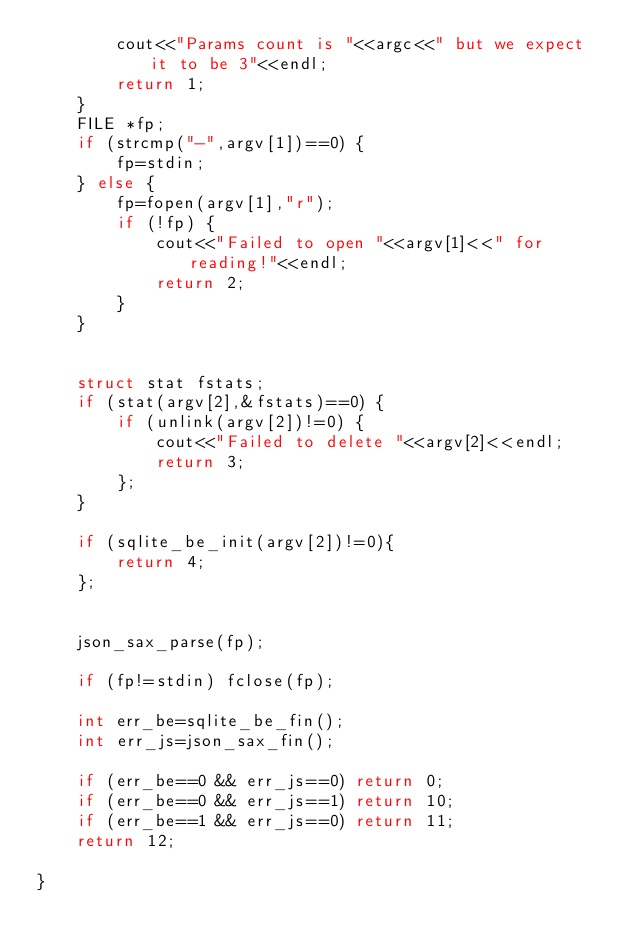Convert code to text. <code><loc_0><loc_0><loc_500><loc_500><_C++_>		cout<<"Params count is "<<argc<<" but we expect it to be 3"<<endl;
		return 1;
	}
	FILE *fp;
	if (strcmp("-",argv[1])==0) {
		fp=stdin;
	} else {
		fp=fopen(argv[1],"r");
		if (!fp) {
			cout<<"Failed to open "<<argv[1]<<" for reading!"<<endl;
			return 2;
		}
	}
	

	struct stat fstats;
	if (stat(argv[2],&fstats)==0) {
		if (unlink(argv[2])!=0) {
			cout<<"Failed to delete "<<argv[2]<<endl;
			return 3;
		};
	}

	if (sqlite_be_init(argv[2])!=0){
		return 4;
	};


	json_sax_parse(fp);

	if (fp!=stdin) fclose(fp);

	int err_be=sqlite_be_fin();
	int err_js=json_sax_fin();

	if (err_be==0 && err_js==0) return 0;
	if (err_be==0 && err_js==1) return 10;
	if (err_be==1 && err_js==0) return 11;
	return 12;

}
</code> 